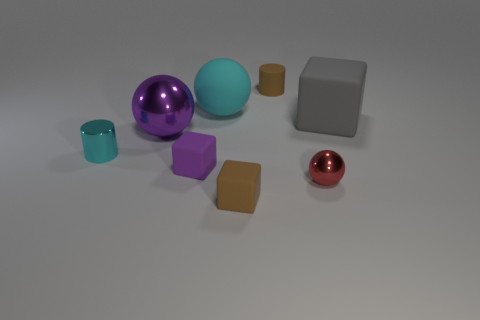What is the shape of the tiny brown thing that is in front of the small shiny cylinder in front of the gray rubber thing?
Offer a terse response. Cube. There is a tiny shiny thing that is the same shape as the large cyan thing; what color is it?
Offer a terse response. Red. There is a brown matte object behind the red metallic thing; is it the same size as the red sphere?
Ensure brevity in your answer.  Yes. The tiny rubber object that is the same color as the matte cylinder is what shape?
Offer a terse response. Cube. How many gray things have the same material as the purple block?
Give a very brief answer. 1. What is the material of the cube in front of the ball right of the cyan thing that is behind the cyan shiny cylinder?
Your answer should be very brief. Rubber. What is the color of the rubber cube that is in front of the block that is to the left of the cyan rubber object?
Provide a short and direct response. Brown. The rubber cylinder that is the same size as the red metallic object is what color?
Offer a very short reply. Brown. What number of small objects are either rubber things or purple rubber blocks?
Ensure brevity in your answer.  3. Is the number of tiny brown cylinders that are left of the brown rubber cylinder greater than the number of brown rubber cylinders in front of the cyan metallic object?
Your answer should be very brief. No. 